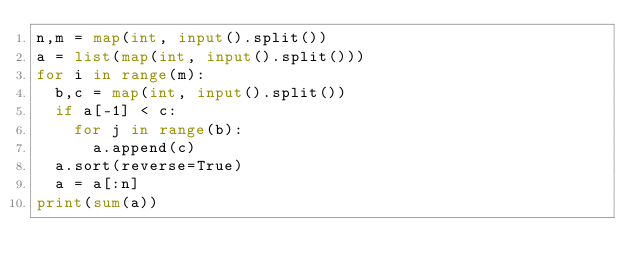Convert code to text. <code><loc_0><loc_0><loc_500><loc_500><_Python_>n,m = map(int, input().split())
a = list(map(int, input().split()))
for i in range(m):
  b,c = map(int, input().split())
  if a[-1] < c:
    for j in range(b):
      a.append(c)
  a.sort(reverse=True)
  a = a[:n]
print(sum(a))
</code> 